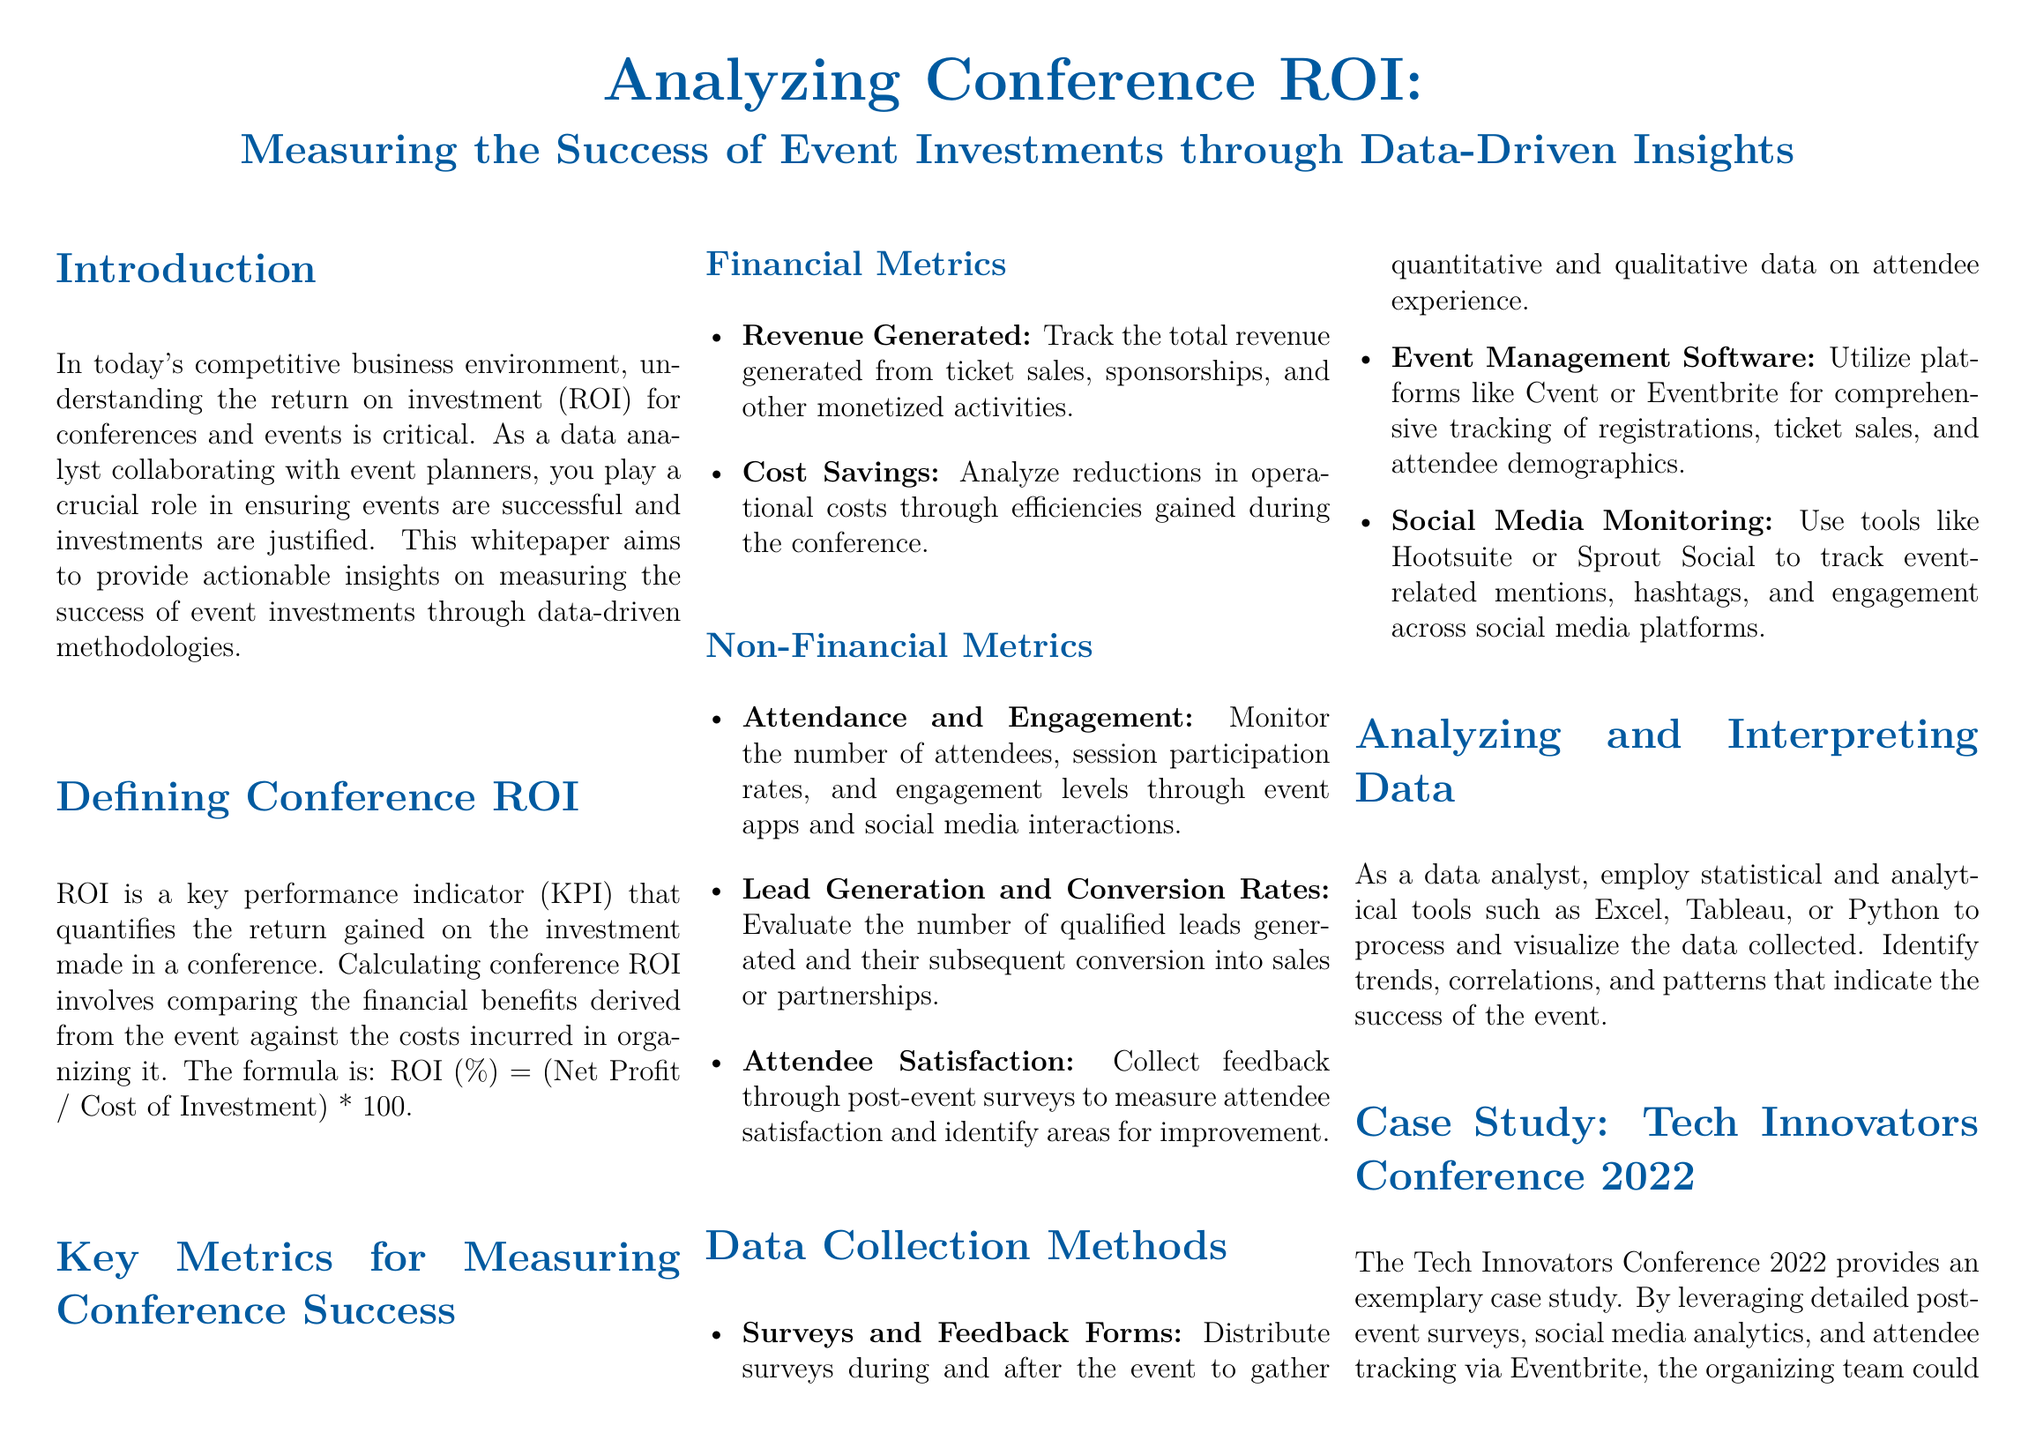What is the formula for calculating ROI? The formula given in the document for calculating conference ROI is: ROI (%) = (Net Profit / Cost of Investment) * 100.
Answer: ROI (%) = (Net Profit / Cost of Investment) * 100 What is the attendee satisfaction rate for the Tech Innovators Conference 2022? The document states that the attendee satisfaction rate for the Tech Innovators Conference 2022 was directly attributed to specific conference sessions and activities.
Answer: 90% What are two financial metrics mentioned in the document? The document lists two financial metrics for measuring conference success, which are Revenue Generated and Cost Savings.
Answer: Revenue Generated, Cost Savings What data collection method involves distributing surveys? The document mentions Surveys and Feedback Forms as a method to gather quantitative and qualitative data.
Answer: Surveys and Feedback Forms What was the final ROI for the Tech Innovators Conference 2022? According to the case study in the document, the final ROI for the Tech Innovators Conference 2022 was calculated at 45%.
Answer: 45% Which tools are suggested for social media monitoring in the document? The document suggests using tools like Hootsuite or Sprout Social for tracking event-related mentions and engagement across social media platforms.
Answer: Hootsuite, Sprout Social What is the primary role of data analysts according to the introduction? The introduction states that data analysts collaborate with event planners to ensure events are successful and investments are justified.
Answer: Collaborate with event planners What types of metrics are divided into financial and non-financial categories? The document divides metrics into two categories: financial metrics and non-financial metrics, indicating different areas of measurement for conference success.
Answer: Financial metrics, non-financial metrics 